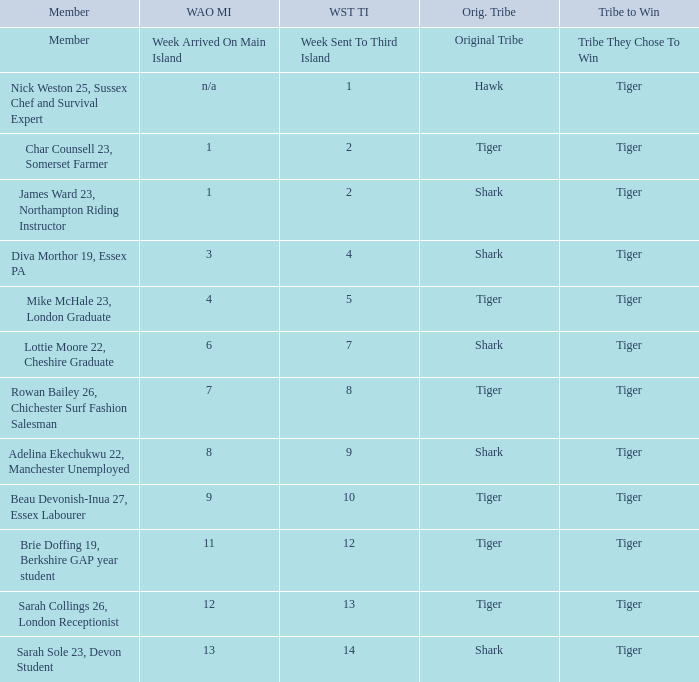Who was sent to the third island in week 1? Nick Weston 25, Sussex Chef and Survival Expert. 